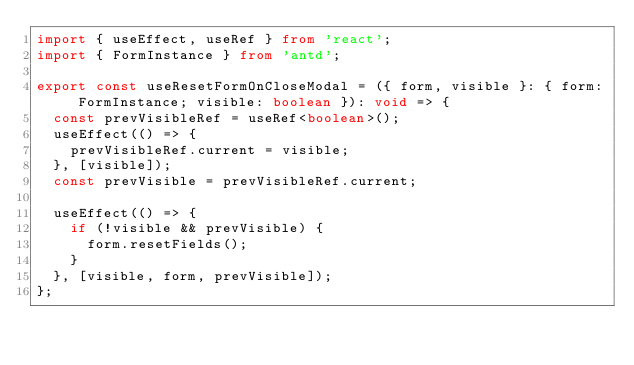<code> <loc_0><loc_0><loc_500><loc_500><_TypeScript_>import { useEffect, useRef } from 'react';
import { FormInstance } from 'antd';

export const useResetFormOnCloseModal = ({ form, visible }: { form: FormInstance; visible: boolean }): void => {
  const prevVisibleRef = useRef<boolean>();
  useEffect(() => {
    prevVisibleRef.current = visible;
  }, [visible]);
  const prevVisible = prevVisibleRef.current;

  useEffect(() => {
    if (!visible && prevVisible) {
      form.resetFields();
    }
  }, [visible, form, prevVisible]);
};
</code> 